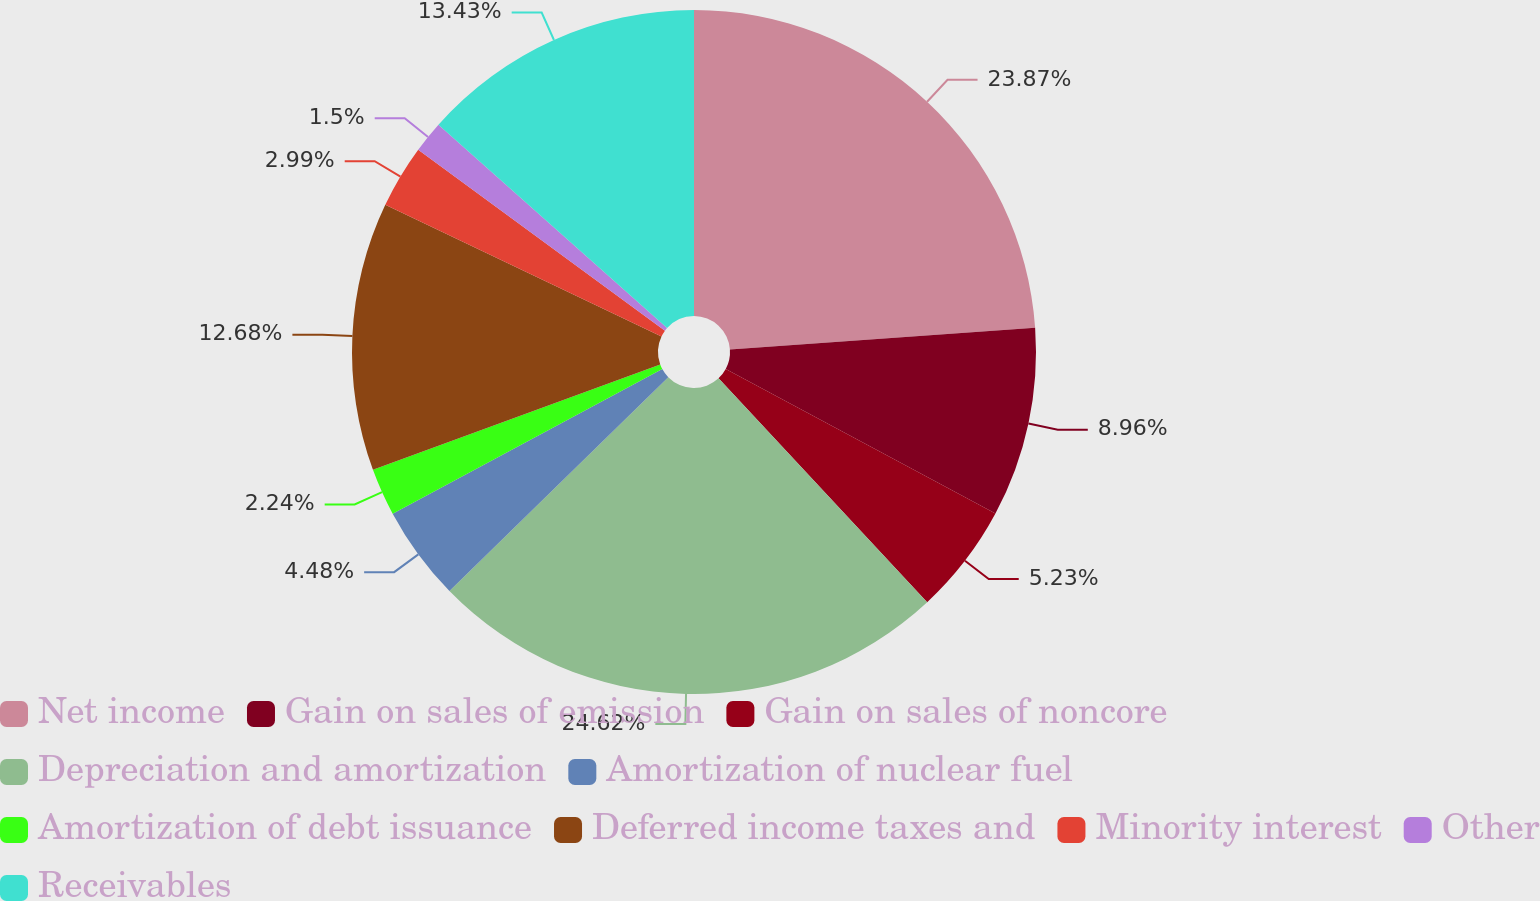Convert chart to OTSL. <chart><loc_0><loc_0><loc_500><loc_500><pie_chart><fcel>Net income<fcel>Gain on sales of emission<fcel>Gain on sales of noncore<fcel>Depreciation and amortization<fcel>Amortization of nuclear fuel<fcel>Amortization of debt issuance<fcel>Deferred income taxes and<fcel>Minority interest<fcel>Other<fcel>Receivables<nl><fcel>23.87%<fcel>8.96%<fcel>5.23%<fcel>24.62%<fcel>4.48%<fcel>2.24%<fcel>12.68%<fcel>2.99%<fcel>1.5%<fcel>13.43%<nl></chart> 